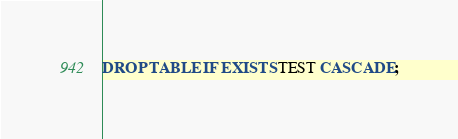Convert code to text. <code><loc_0><loc_0><loc_500><loc_500><_SQL_>DROP TABLE IF EXISTS TEST CASCADE;</code> 